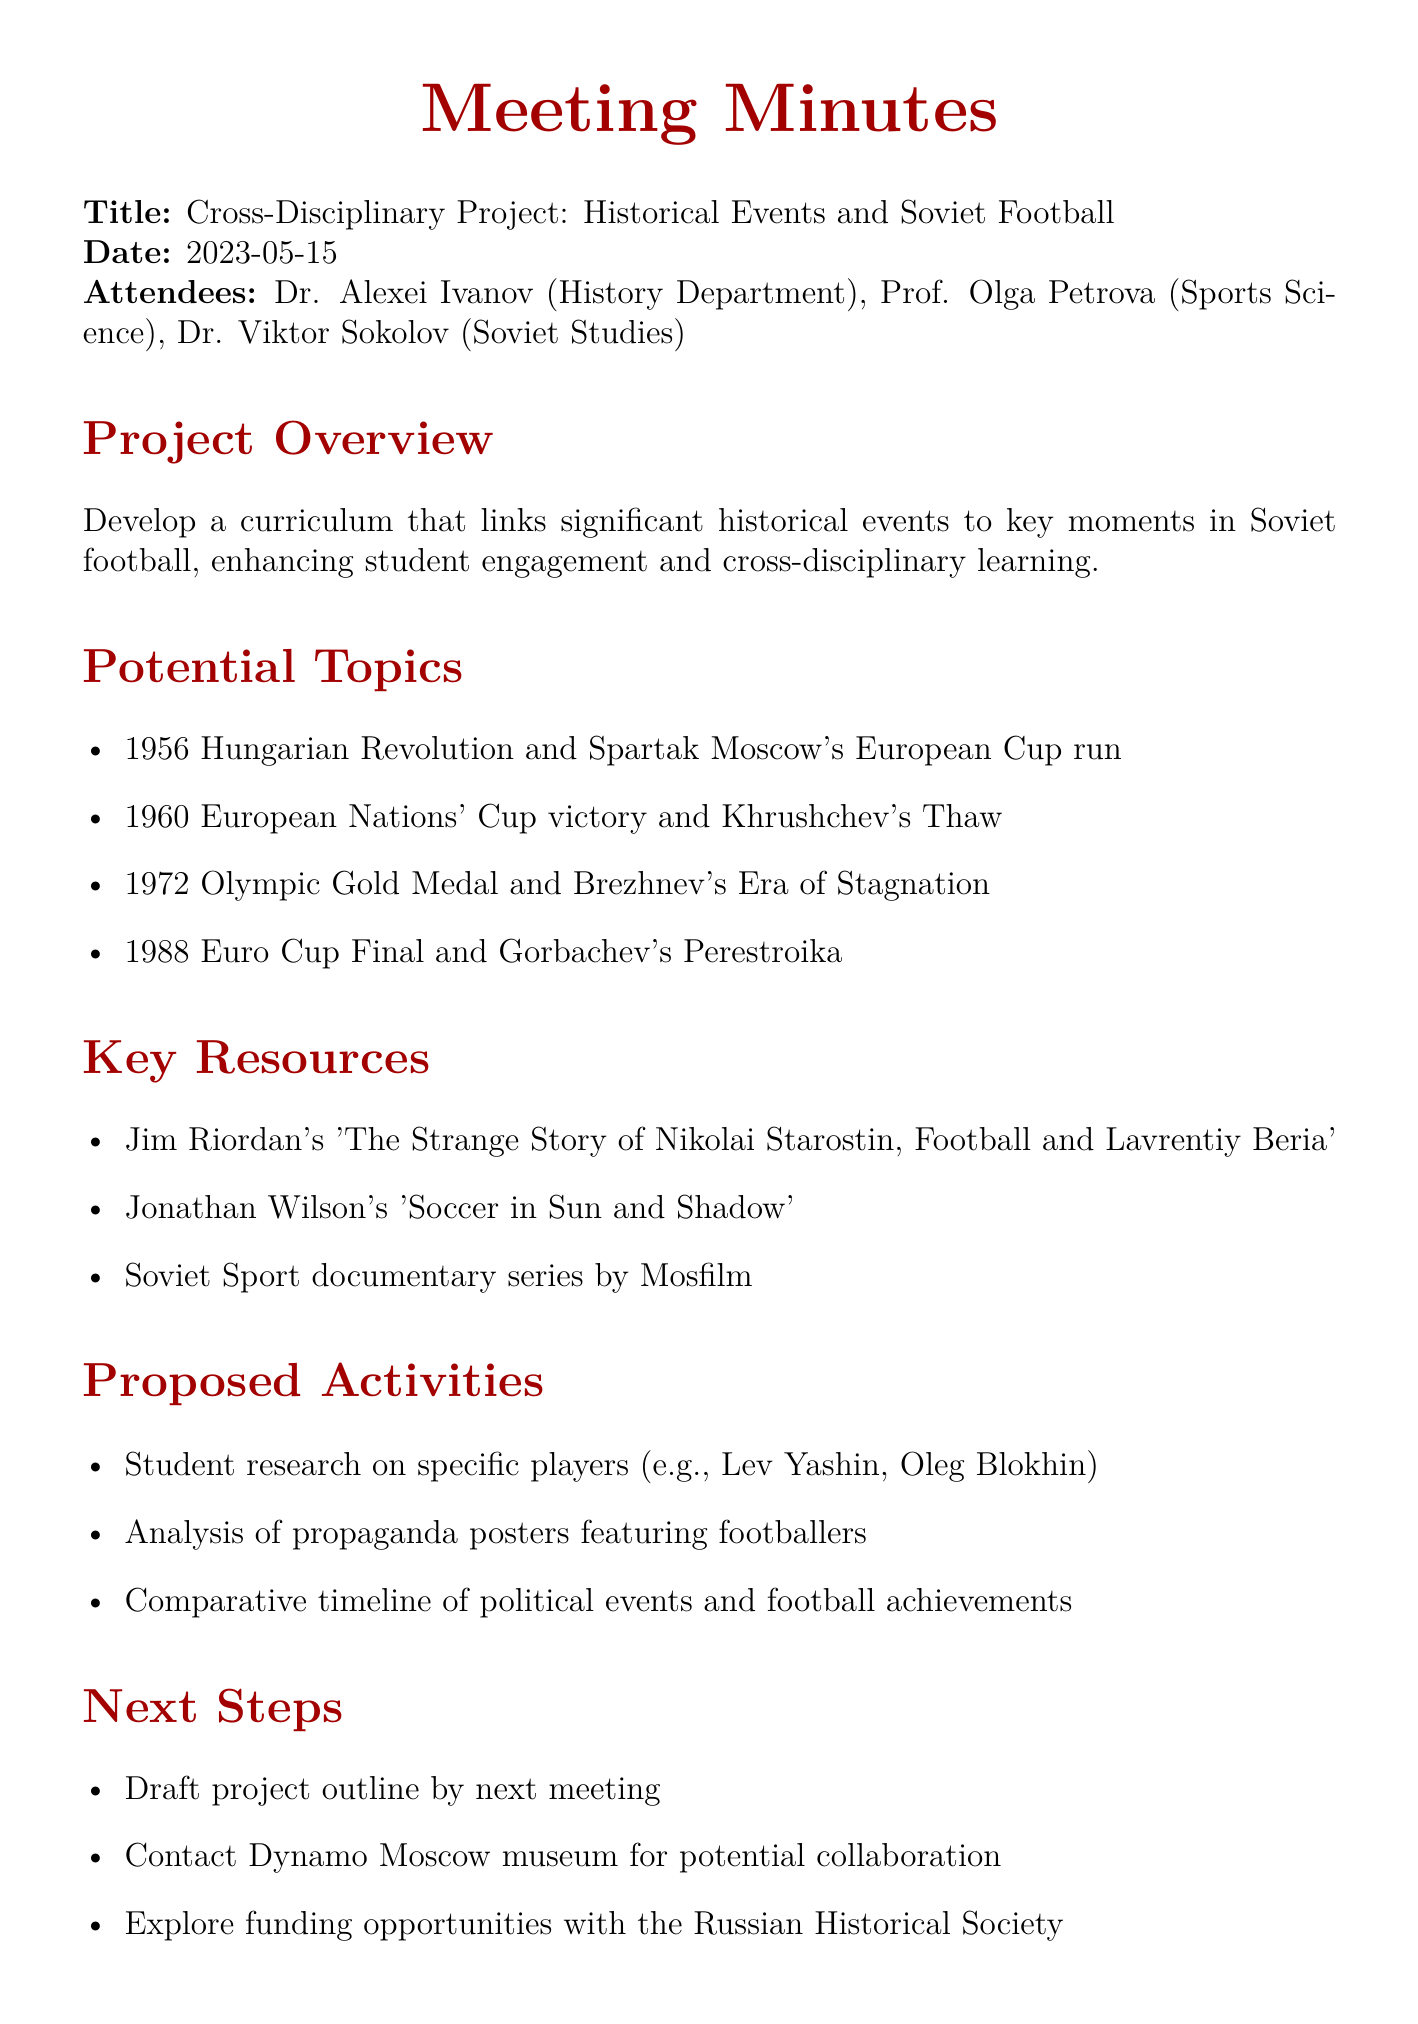What is the meeting title? The meeting title is the main subject of the document, which summarizes the purpose of the meeting.
Answer: Cross-Disciplinary Project: Historical Events and Soviet Football Who attended the meeting? The attendees list includes all individuals participating in the meeting, identified by their titles and departments.
Answer: Dr. Alexei Ivanov, Prof. Olga Petrova, Dr. Viktor Sokolov What is one potential topic discussed? The potential topics are key ideas outlined for the project, which link football moments to historical events.
Answer: 1956 Hungarian Revolution and Spartak Moscow's European Cup run What is one key resource mentioned? Key resources are essential materials and references identified for the project to aid research and learning.
Answer: Jim Riordan's 'The Strange Story of Nikolai Starostin, Football and Lavrentiy Beria' What is one proposed activity for students? Proposed activities are specific actions planned for students to engage with the curriculum and enhance learning.
Answer: Student research on specific players What is the date of the meeting? The date indicates when the meeting was held, providing a timeframe for the discussions and decisions made.
Answer: 2023-05-15 What is one next step that was identified? Next steps outline the immediate actions to be taken following the meeting to ensure project progress.
Answer: Draft project outline by next meeting 